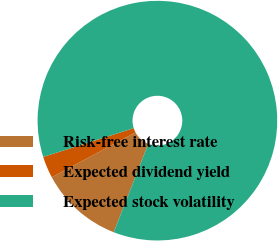Convert chart to OTSL. <chart><loc_0><loc_0><loc_500><loc_500><pie_chart><fcel>Risk-free interest rate<fcel>Expected dividend yield<fcel>Expected stock volatility<nl><fcel>11.23%<fcel>2.94%<fcel>85.83%<nl></chart> 